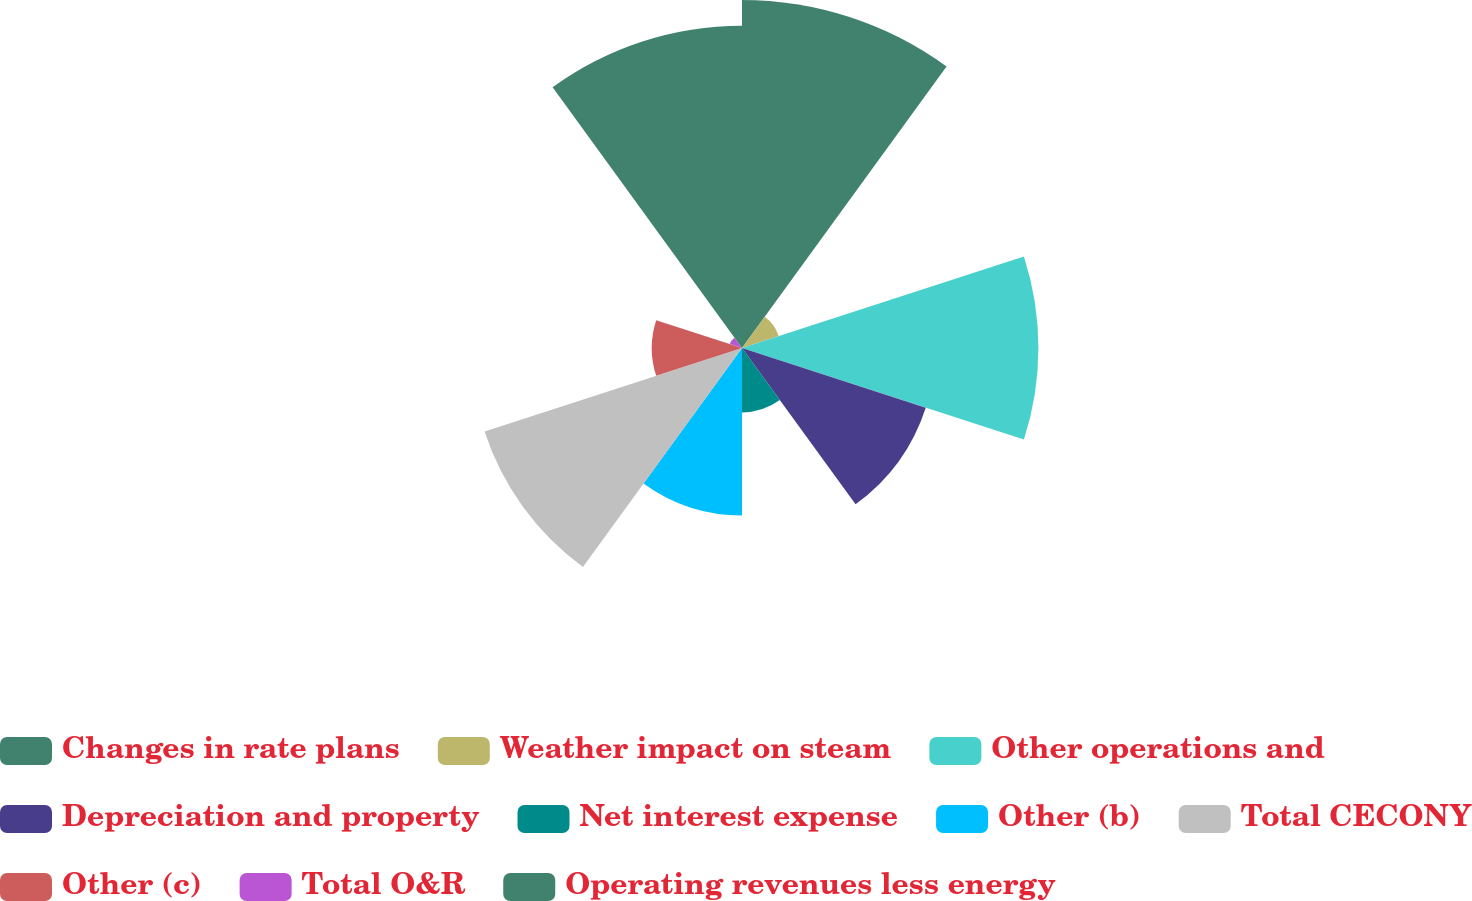Convert chart. <chart><loc_0><loc_0><loc_500><loc_500><pie_chart><fcel>Changes in rate plans<fcel>Weather impact on steam<fcel>Other operations and<fcel>Depreciation and property<fcel>Net interest expense<fcel>Other (b)<fcel>Total CECONY<fcel>Other (c)<fcel>Total O&R<fcel>Operating revenues less energy<nl><fcel>19.29%<fcel>2.14%<fcel>16.43%<fcel>10.71%<fcel>3.57%<fcel>9.29%<fcel>15.0%<fcel>5.0%<fcel>0.71%<fcel>17.86%<nl></chart> 